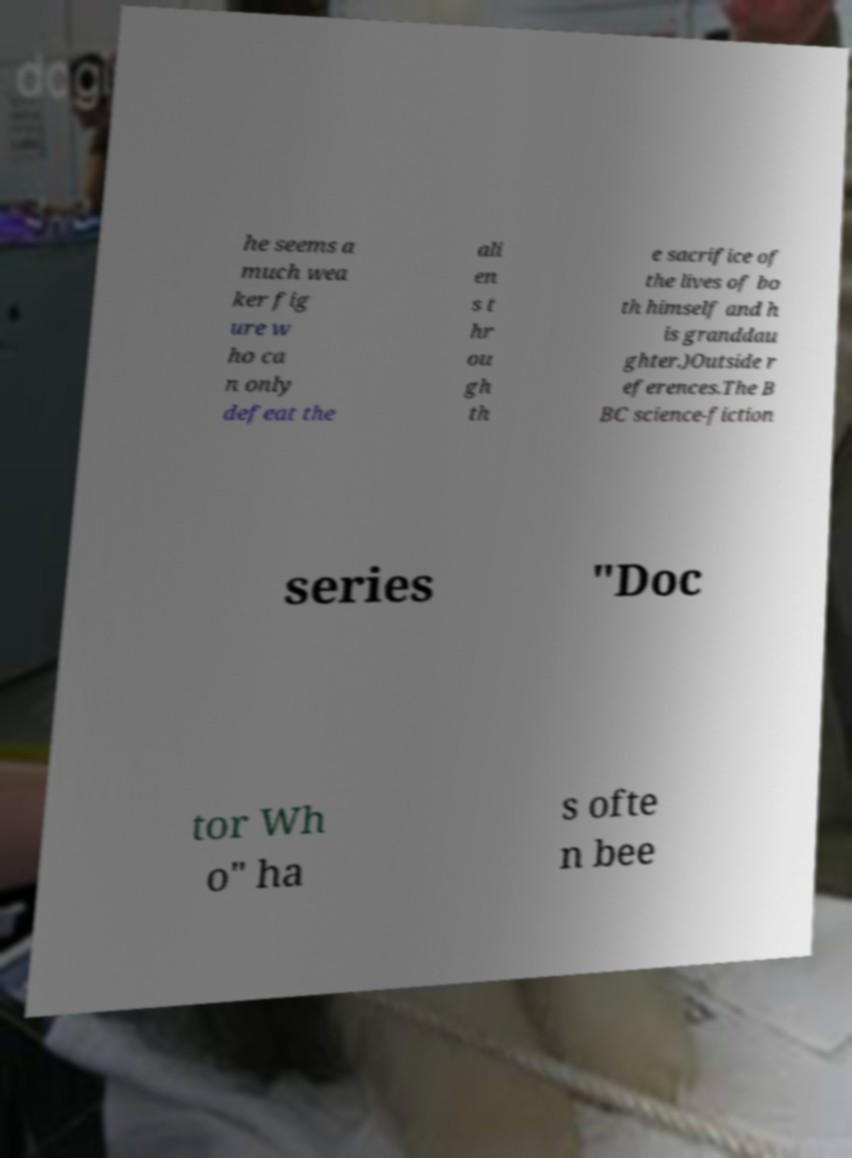What messages or text are displayed in this image? I need them in a readable, typed format. he seems a much wea ker fig ure w ho ca n only defeat the ali en s t hr ou gh th e sacrifice of the lives of bo th himself and h is granddau ghter.)Outside r eferences.The B BC science-fiction series "Doc tor Wh o" ha s ofte n bee 